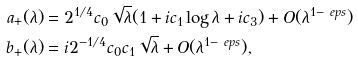Convert formula to latex. <formula><loc_0><loc_0><loc_500><loc_500>a _ { + } ( \lambda ) & = 2 ^ { 1 / 4 } c _ { 0 } \sqrt { \lambda } ( 1 + i c _ { 1 } \log \lambda + i c _ { 3 } ) + O ( \lambda ^ { 1 - \ e p s } ) \\ b _ { + } ( \lambda ) & = i 2 ^ { - 1 / 4 } c _ { 0 } c _ { 1 } \sqrt { \lambda } + O ( \lambda ^ { 1 - \ e p s } ) ,</formula> 